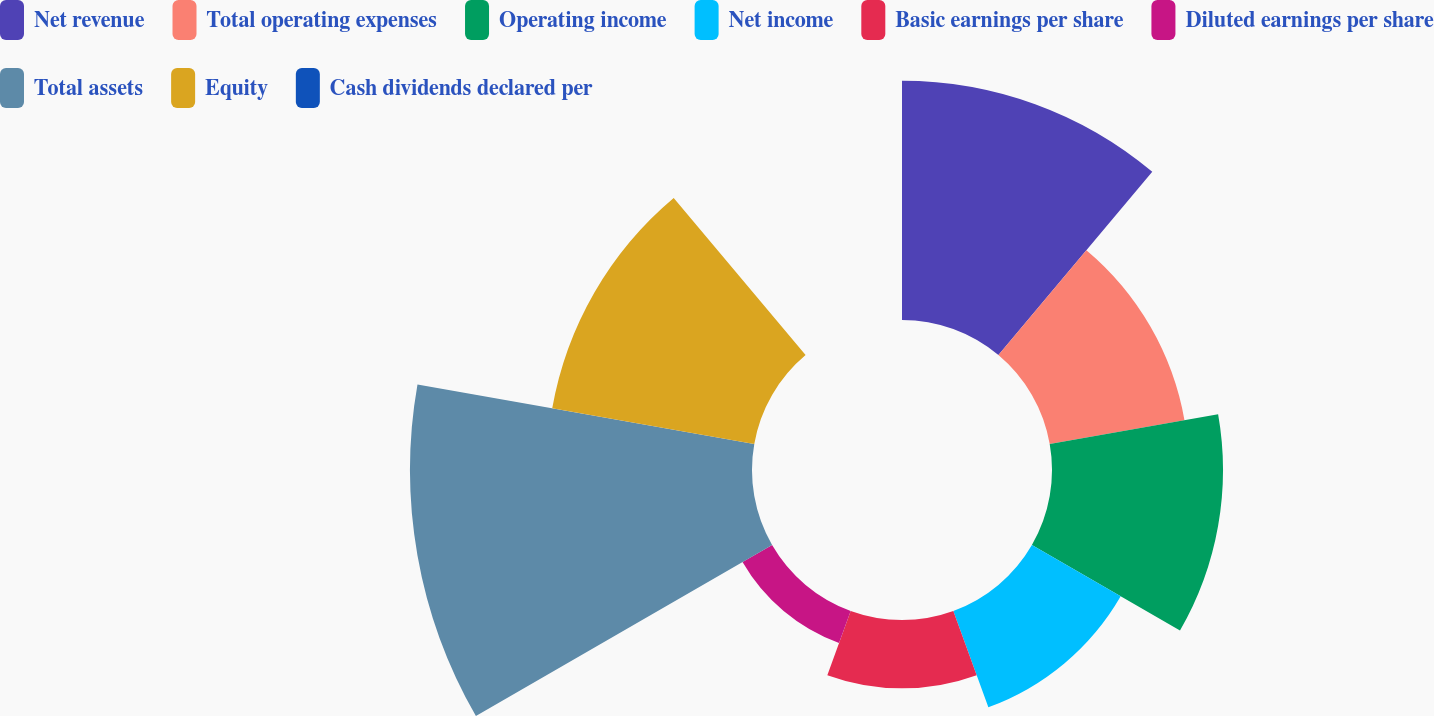Convert chart to OTSL. <chart><loc_0><loc_0><loc_500><loc_500><pie_chart><fcel>Net revenue<fcel>Total operating expenses<fcel>Operating income<fcel>Net income<fcel>Basic earnings per share<fcel>Diluted earnings per share<fcel>Total assets<fcel>Equity<fcel>Cash dividends declared per<nl><fcel>18.42%<fcel>10.53%<fcel>13.16%<fcel>7.89%<fcel>5.26%<fcel>2.63%<fcel>26.32%<fcel>15.79%<fcel>0.0%<nl></chart> 